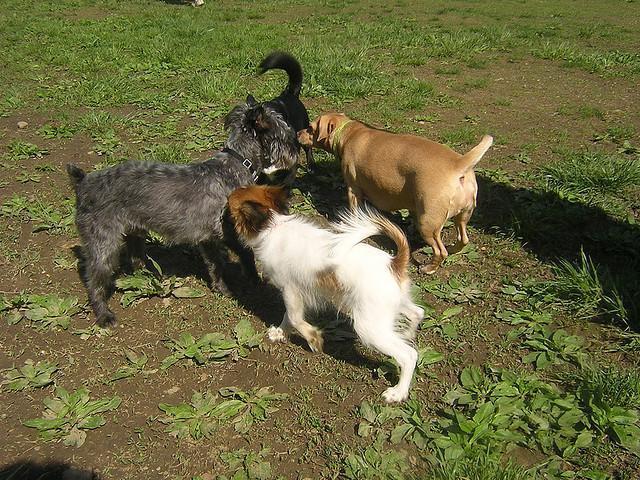How many pets are shown?
Give a very brief answer. 4. How many animals are there?
Give a very brief answer. 4. How many dogs are there?
Give a very brief answer. 4. 